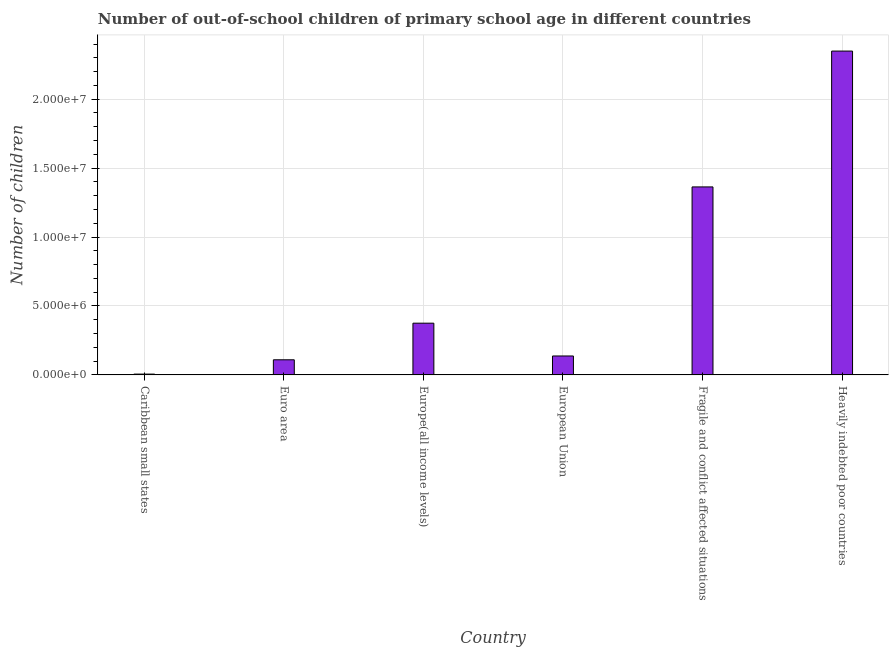What is the title of the graph?
Your answer should be compact. Number of out-of-school children of primary school age in different countries. What is the label or title of the X-axis?
Provide a short and direct response. Country. What is the label or title of the Y-axis?
Give a very brief answer. Number of children. What is the number of out-of-school children in Euro area?
Keep it short and to the point. 1.10e+06. Across all countries, what is the maximum number of out-of-school children?
Your answer should be very brief. 2.35e+07. Across all countries, what is the minimum number of out-of-school children?
Your response must be concise. 5.90e+04. In which country was the number of out-of-school children maximum?
Your response must be concise. Heavily indebted poor countries. In which country was the number of out-of-school children minimum?
Provide a short and direct response. Caribbean small states. What is the sum of the number of out-of-school children?
Your response must be concise. 4.34e+07. What is the difference between the number of out-of-school children in Caribbean small states and Europe(all income levels)?
Offer a very short reply. -3.69e+06. What is the average number of out-of-school children per country?
Your answer should be very brief. 7.24e+06. What is the median number of out-of-school children?
Make the answer very short. 2.56e+06. What is the ratio of the number of out-of-school children in Caribbean small states to that in European Union?
Make the answer very short. 0.04. What is the difference between the highest and the second highest number of out-of-school children?
Ensure brevity in your answer.  9.85e+06. What is the difference between the highest and the lowest number of out-of-school children?
Make the answer very short. 2.34e+07. How many bars are there?
Give a very brief answer. 6. Are all the bars in the graph horizontal?
Ensure brevity in your answer.  No. How many countries are there in the graph?
Ensure brevity in your answer.  6. What is the Number of children of Caribbean small states?
Make the answer very short. 5.90e+04. What is the Number of children in Euro area?
Provide a short and direct response. 1.10e+06. What is the Number of children in Europe(all income levels)?
Give a very brief answer. 3.75e+06. What is the Number of children in European Union?
Your response must be concise. 1.37e+06. What is the Number of children in Fragile and conflict affected situations?
Provide a short and direct response. 1.36e+07. What is the Number of children in Heavily indebted poor countries?
Offer a terse response. 2.35e+07. What is the difference between the Number of children in Caribbean small states and Euro area?
Offer a very short reply. -1.04e+06. What is the difference between the Number of children in Caribbean small states and Europe(all income levels)?
Make the answer very short. -3.69e+06. What is the difference between the Number of children in Caribbean small states and European Union?
Your answer should be very brief. -1.31e+06. What is the difference between the Number of children in Caribbean small states and Fragile and conflict affected situations?
Give a very brief answer. -1.36e+07. What is the difference between the Number of children in Caribbean small states and Heavily indebted poor countries?
Keep it short and to the point. -2.34e+07. What is the difference between the Number of children in Euro area and Europe(all income levels)?
Make the answer very short. -2.66e+06. What is the difference between the Number of children in Euro area and European Union?
Provide a succinct answer. -2.76e+05. What is the difference between the Number of children in Euro area and Fragile and conflict affected situations?
Your answer should be compact. -1.25e+07. What is the difference between the Number of children in Euro area and Heavily indebted poor countries?
Ensure brevity in your answer.  -2.24e+07. What is the difference between the Number of children in Europe(all income levels) and European Union?
Your answer should be compact. 2.38e+06. What is the difference between the Number of children in Europe(all income levels) and Fragile and conflict affected situations?
Make the answer very short. -9.89e+06. What is the difference between the Number of children in Europe(all income levels) and Heavily indebted poor countries?
Your answer should be compact. -1.97e+07. What is the difference between the Number of children in European Union and Fragile and conflict affected situations?
Provide a short and direct response. -1.23e+07. What is the difference between the Number of children in European Union and Heavily indebted poor countries?
Ensure brevity in your answer.  -2.21e+07. What is the difference between the Number of children in Fragile and conflict affected situations and Heavily indebted poor countries?
Ensure brevity in your answer.  -9.85e+06. What is the ratio of the Number of children in Caribbean small states to that in Euro area?
Make the answer very short. 0.05. What is the ratio of the Number of children in Caribbean small states to that in Europe(all income levels)?
Make the answer very short. 0.02. What is the ratio of the Number of children in Caribbean small states to that in European Union?
Your response must be concise. 0.04. What is the ratio of the Number of children in Caribbean small states to that in Fragile and conflict affected situations?
Offer a terse response. 0. What is the ratio of the Number of children in Caribbean small states to that in Heavily indebted poor countries?
Make the answer very short. 0. What is the ratio of the Number of children in Euro area to that in Europe(all income levels)?
Keep it short and to the point. 0.29. What is the ratio of the Number of children in Euro area to that in European Union?
Provide a succinct answer. 0.8. What is the ratio of the Number of children in Euro area to that in Heavily indebted poor countries?
Your answer should be compact. 0.05. What is the ratio of the Number of children in Europe(all income levels) to that in European Union?
Give a very brief answer. 2.73. What is the ratio of the Number of children in Europe(all income levels) to that in Fragile and conflict affected situations?
Your answer should be compact. 0.28. What is the ratio of the Number of children in Europe(all income levels) to that in Heavily indebted poor countries?
Provide a short and direct response. 0.16. What is the ratio of the Number of children in European Union to that in Fragile and conflict affected situations?
Provide a short and direct response. 0.1. What is the ratio of the Number of children in European Union to that in Heavily indebted poor countries?
Provide a succinct answer. 0.06. What is the ratio of the Number of children in Fragile and conflict affected situations to that in Heavily indebted poor countries?
Provide a succinct answer. 0.58. 